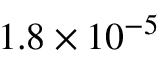Convert formula to latex. <formula><loc_0><loc_0><loc_500><loc_500>1 . 8 \times 1 0 ^ { - 5 }</formula> 